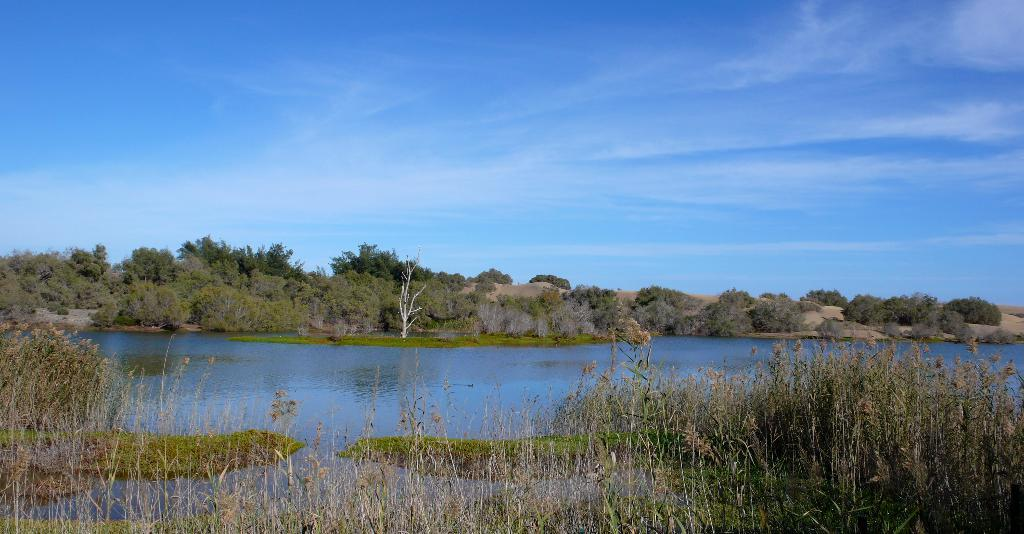What is the main feature of the image? The main feature of the image is water. What type of vegetation is present on the land in the image? There is grass and trees on the land in the image. What other plants can be seen in the image? There are plants at the bottom of the image. What part of the natural environment is visible in the image? The sky is visible at the top of the image. How does the development of the area affect the steam coming from the water in the image? There is no steam coming from the water in the image, and no development is mentioned or depicted. 